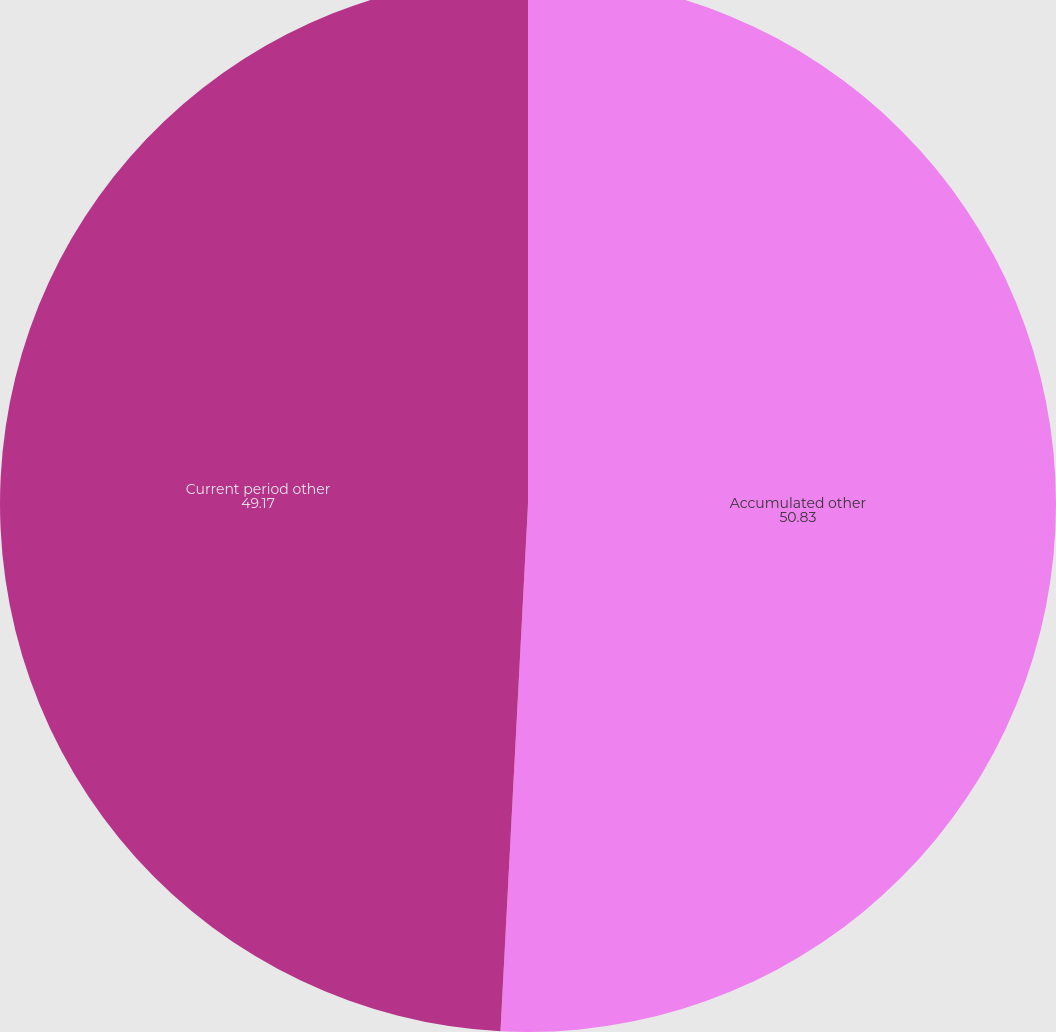Convert chart to OTSL. <chart><loc_0><loc_0><loc_500><loc_500><pie_chart><fcel>Accumulated other<fcel>Current period other<nl><fcel>50.83%<fcel>49.17%<nl></chart> 